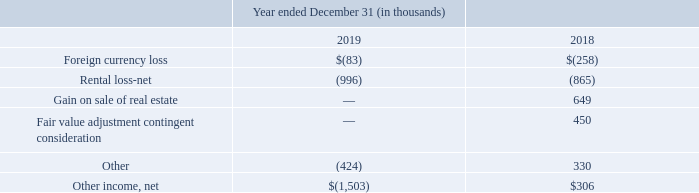Other income, net
The components of other income, net from continuing operations for the years ended December 31 are as follows:
In 2018, we recorded a $0.5 million adjustment to decrease the fair value of the Company's contingent consideration related to the Brink Acquisition. Also, during 2019 and 2018, the Company incurred a net loss on rental contracts of approximately $1.0 million and $0.9 million, respectively.
What was the adjustment recorded to decrease the fair value of the Company's contingent consideration related to the Brink Acquisition in 2018? $0.5 million. How much was the net loss on rental contracts during 2019? Approximately $1.0 million. What is the Foreign currency loss in 2019 and 2018 respectively?
Answer scale should be: thousand. $(83), $(258). What is the change in Foreign currency loss between December 31, 2018 and 2019?
Answer scale should be: thousand. (83)-(258)
Answer: 175. What is the change in Rental loss-net between December 31, 2018 and 2019?
Answer scale should be: thousand. (996)-(865)
Answer: -131. What is the average Foreign currency loss for December 31, 2018 and 2019?
Answer scale should be: thousand. (83+258) / 2
Answer: 170.5. 